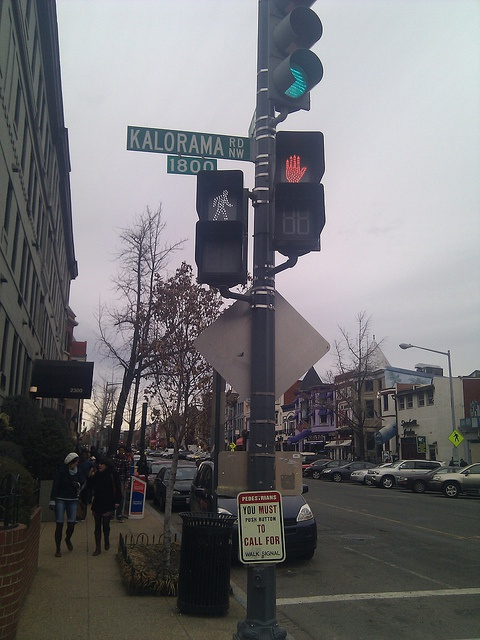Describe the objects in this image and their specific colors. I can see traffic light in black, lightgray, and gray tones, traffic light in black and gray tones, traffic light in black, gray, blue, and teal tones, car in black, gray, and darkgray tones, and people in black tones in this image. 